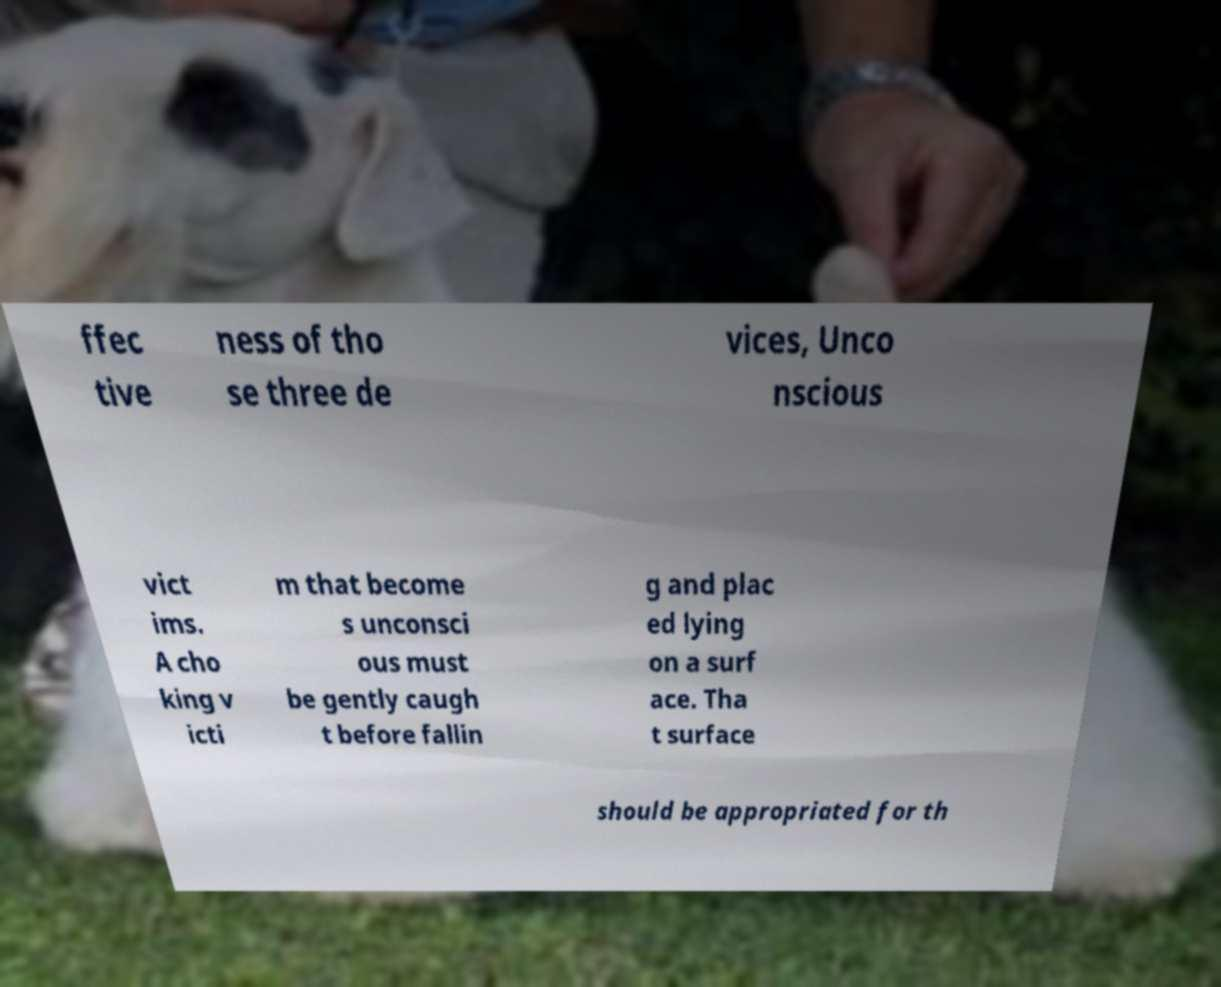There's text embedded in this image that I need extracted. Can you transcribe it verbatim? ffec tive ness of tho se three de vices, Unco nscious vict ims. A cho king v icti m that become s unconsci ous must be gently caugh t before fallin g and plac ed lying on a surf ace. Tha t surface should be appropriated for th 